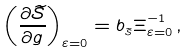<formula> <loc_0><loc_0><loc_500><loc_500>\left ( \frac { \partial \widetilde { \mathcal { S } } } { \partial g } \right ) _ { \varepsilon = 0 } = b _ { _ { \widetilde { \mathcal { S } } } } \Xi _ { \varepsilon = 0 } ^ { - 1 } \, ,</formula> 